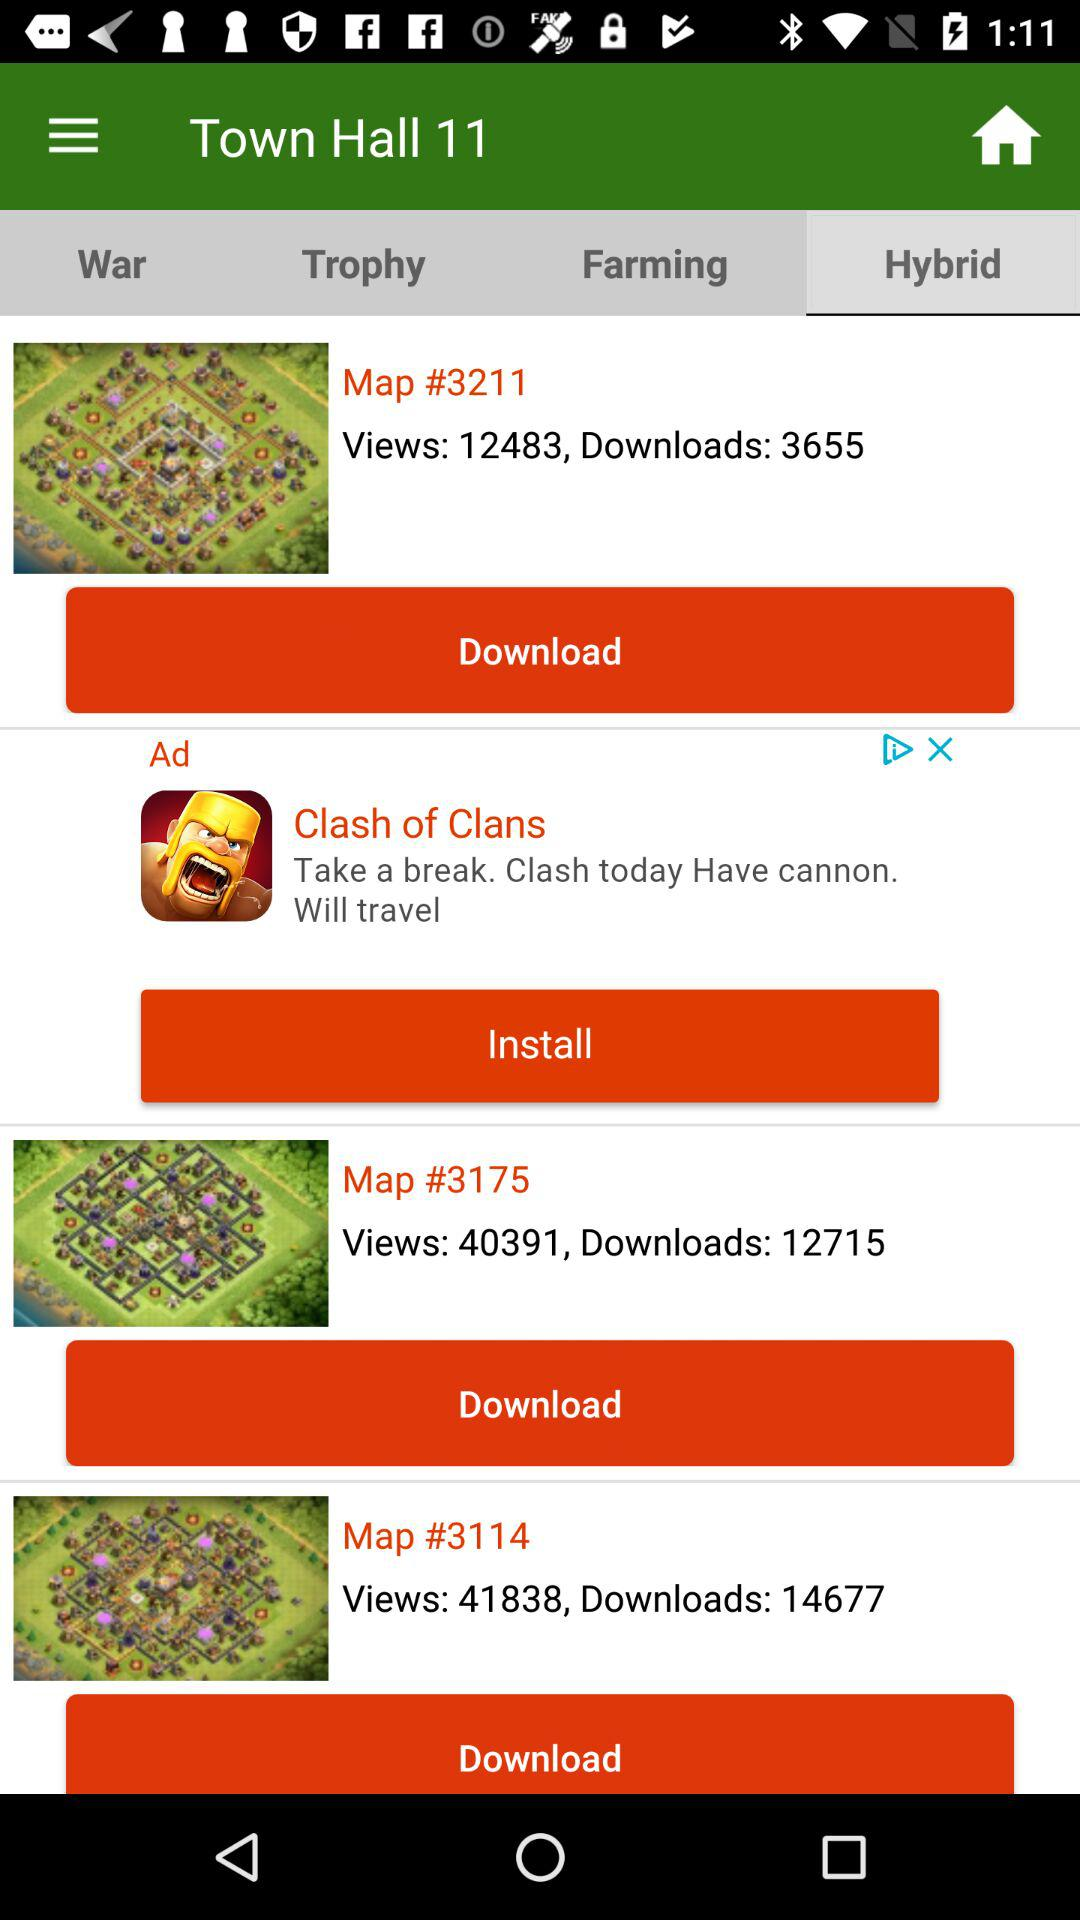How many downloads are there on "Map #3211"? There are 3655 downloads. 